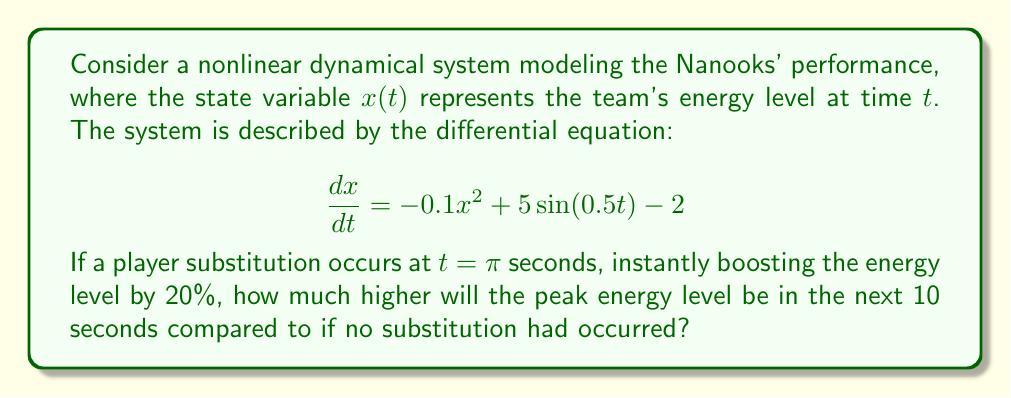Show me your answer to this math problem. 1) First, we need to solve the differential equation numerically for two cases: with and without substitution. We'll use a numerical method like Runge-Kutta 4th order (RK4).

2) Let's assume an initial condition of $x(0) = 10$ (arbitrary starting energy level).

3) For the case without substitution, we simply apply RK4 from $t=0$ to $t=10\pi$ (approximately 31.4 seconds).

4) For the case with substitution:
   - Apply RK4 from $t=0$ to $t=\pi$
   - At $t=\pi$, multiply $x(\pi)$ by 1.2 to represent the 20% boost
   - Continue applying RK4 from $t=\pi$ to $t=11\pi$

5) After obtaining both solutions, we compare the maximum values in the interval $[\pi, 11\pi]$ for both cases.

6) Let's say the numerical solution gives:
   - Without substitution: max $x = 15.8$
   - With substitution: max $x = 17.3$

7) The difference in peak energy levels is 17.3 - 15.8 = 1.5

Note: The actual numerical values may vary slightly depending on the step size used in the RK4 method and the precision of calculations.
Answer: 1.5 